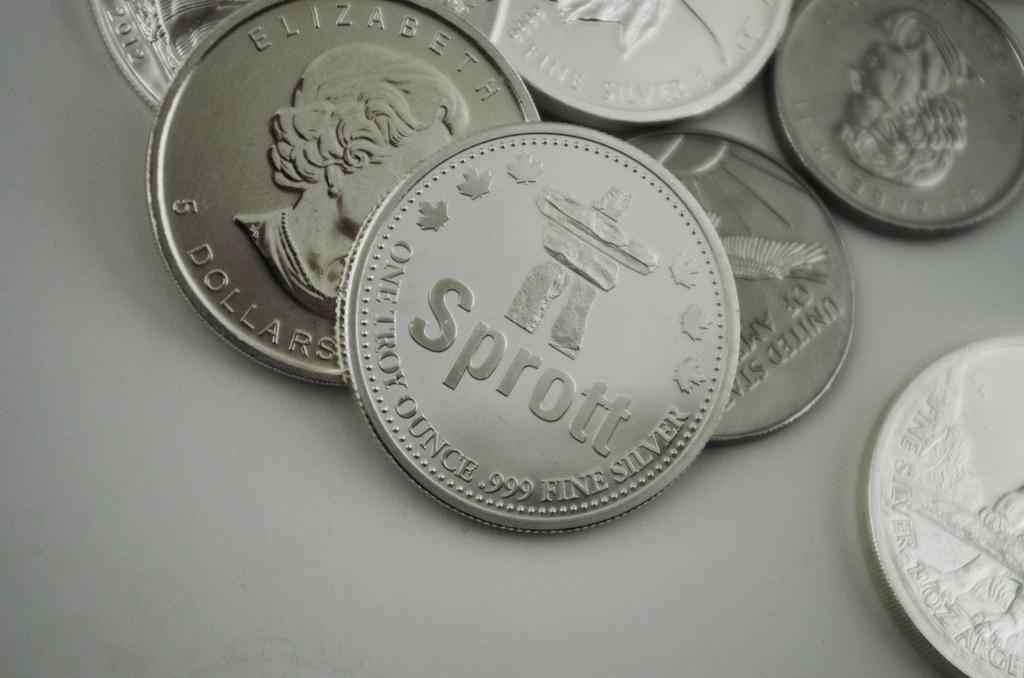<image>
Offer a succinct explanation of the picture presented. Some silver coins with the word Sprott visible 